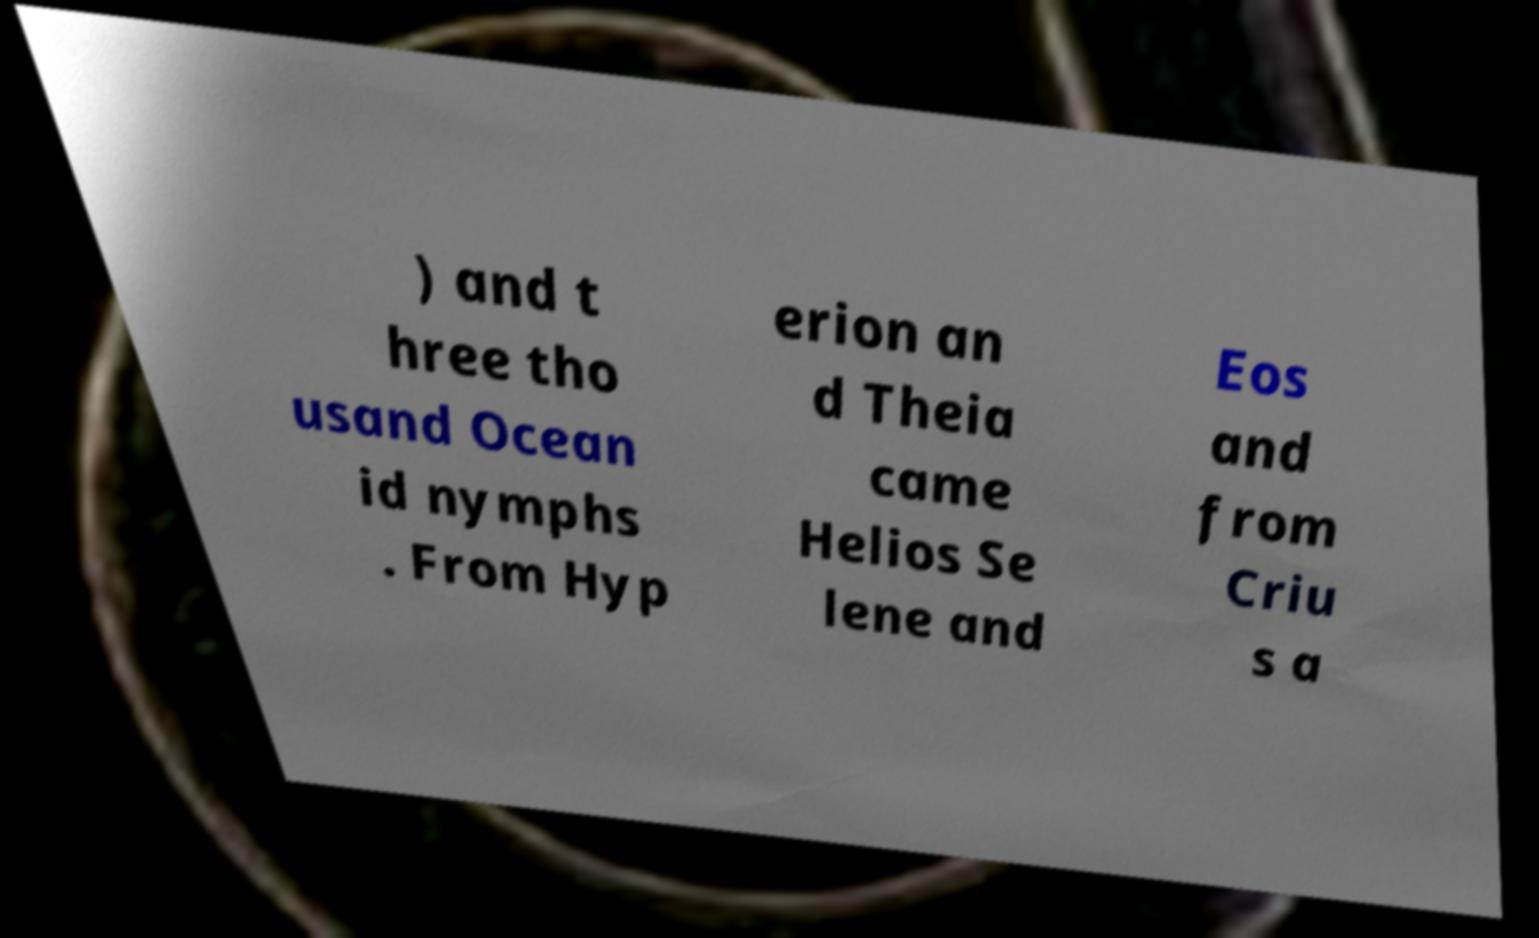For documentation purposes, I need the text within this image transcribed. Could you provide that? ) and t hree tho usand Ocean id nymphs . From Hyp erion an d Theia came Helios Se lene and Eos and from Criu s a 